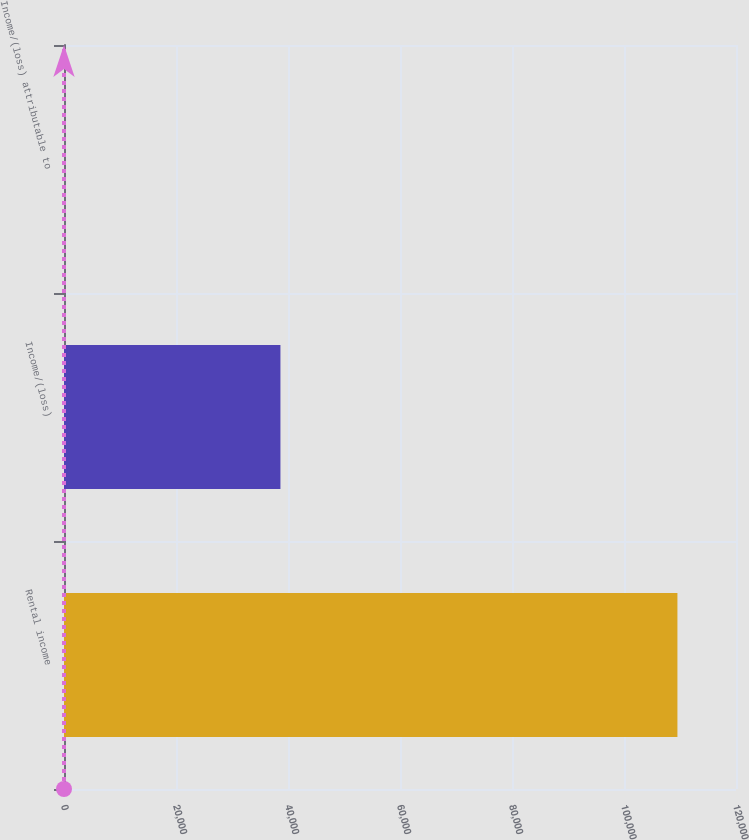Convert chart. <chart><loc_0><loc_0><loc_500><loc_500><bar_chart><fcel>Rental income<fcel>Income/(loss)<fcel>Income/(loss) attributable to<nl><fcel>109539<fcel>38648.9<fcel>0.15<nl></chart> 